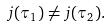<formula> <loc_0><loc_0><loc_500><loc_500>j ( \tau _ { 1 } ) \ne j ( \tau _ { 2 } ) .</formula> 